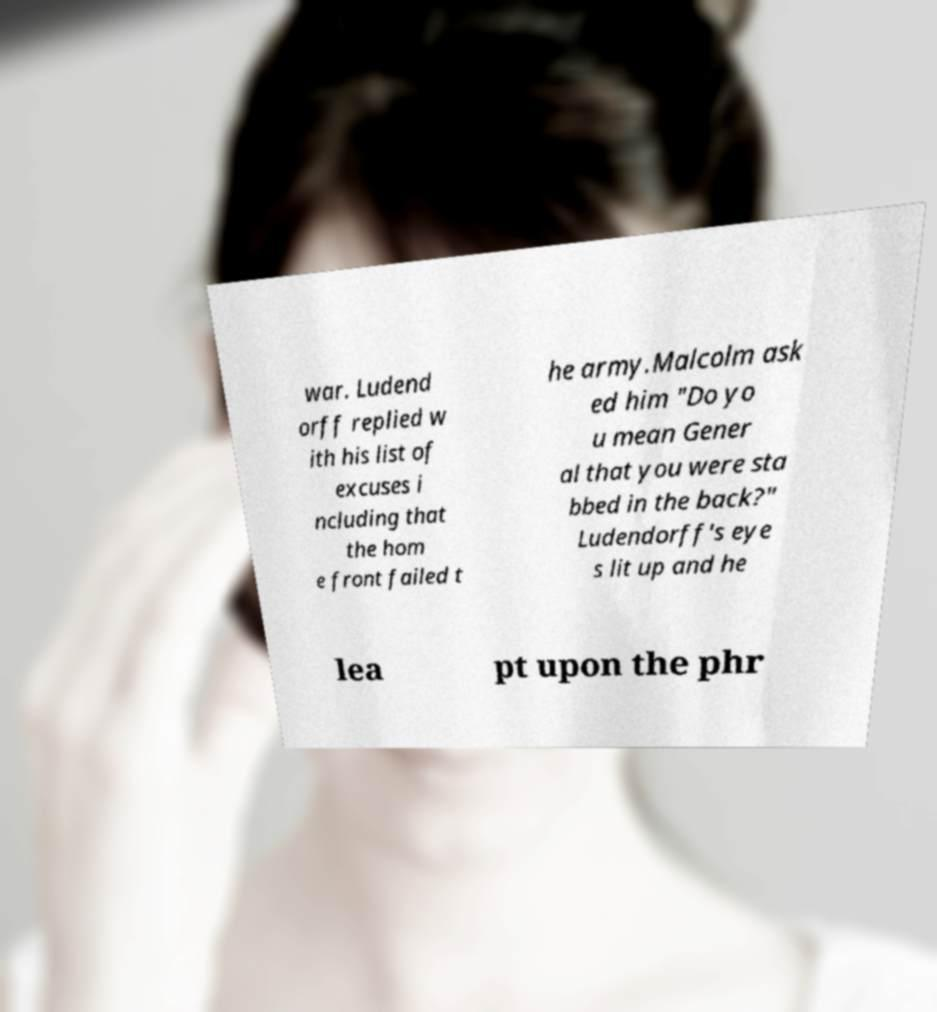I need the written content from this picture converted into text. Can you do that? war. Ludend orff replied w ith his list of excuses i ncluding that the hom e front failed t he army.Malcolm ask ed him "Do yo u mean Gener al that you were sta bbed in the back?" Ludendorff's eye s lit up and he lea pt upon the phr 